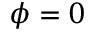Convert formula to latex. <formula><loc_0><loc_0><loc_500><loc_500>\phi = 0</formula> 